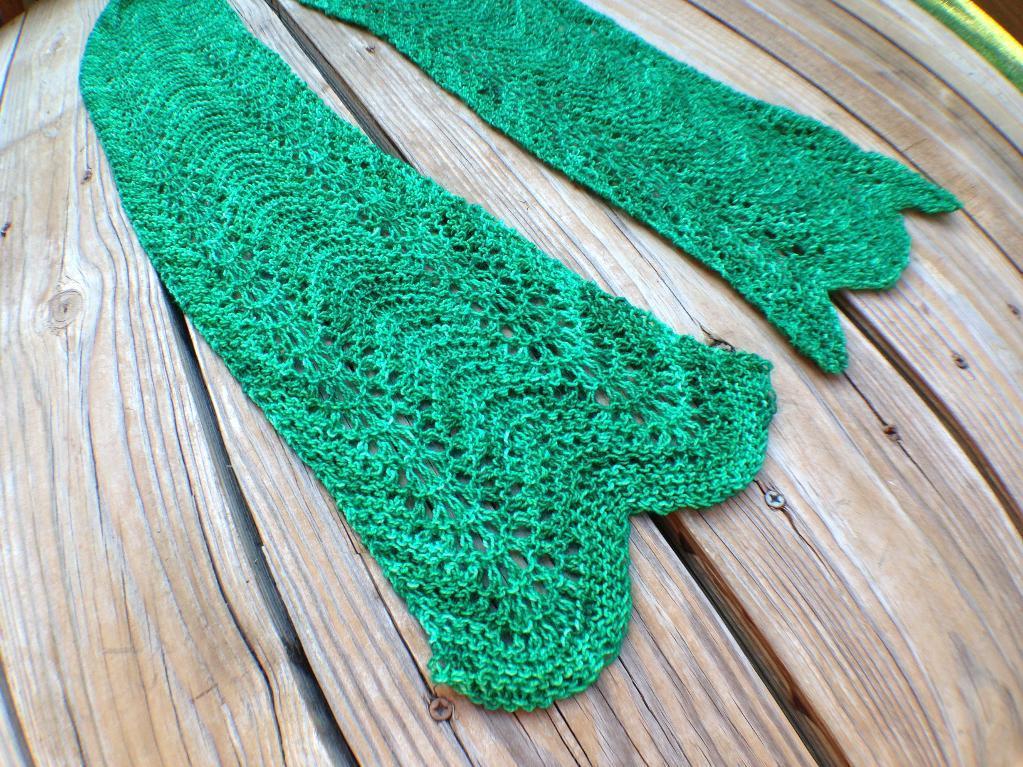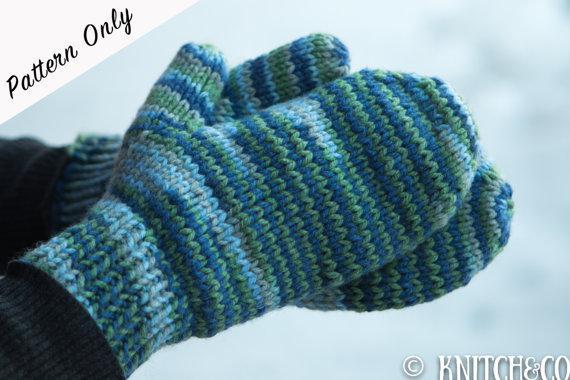The first image is the image on the left, the second image is the image on the right. Examine the images to the left and right. Is the description "The person's skin is visible as they try on the gloves." accurate? Answer yes or no. No. The first image is the image on the left, the second image is the image on the right. Evaluate the accuracy of this statement regarding the images: "Solid color mittens appear in each image, a different color and pattern in each one, with one pair worn by a person.". Is it true? Answer yes or no. No. 